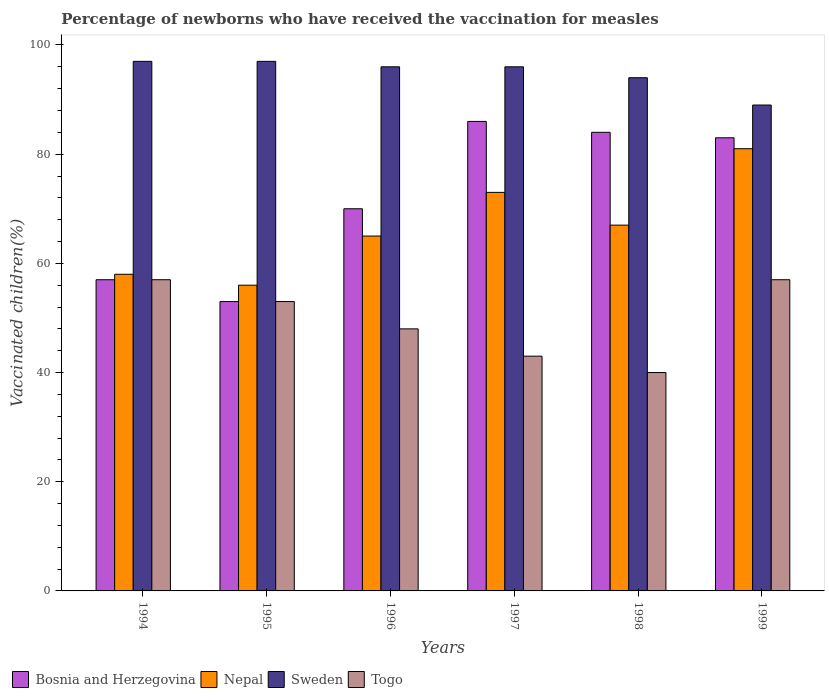How many groups of bars are there?
Your response must be concise. 6. Are the number of bars per tick equal to the number of legend labels?
Your response must be concise. Yes. Across all years, what is the maximum percentage of vaccinated children in Nepal?
Ensure brevity in your answer.  81. Across all years, what is the minimum percentage of vaccinated children in Nepal?
Provide a succinct answer. 56. What is the total percentage of vaccinated children in Nepal in the graph?
Ensure brevity in your answer.  400. What is the difference between the percentage of vaccinated children in Nepal in 1994 and that in 1997?
Provide a succinct answer. -15. What is the difference between the percentage of vaccinated children in Nepal in 1996 and the percentage of vaccinated children in Togo in 1995?
Provide a succinct answer. 12. What is the average percentage of vaccinated children in Bosnia and Herzegovina per year?
Provide a short and direct response. 72.17. In the year 1997, what is the difference between the percentage of vaccinated children in Sweden and percentage of vaccinated children in Nepal?
Ensure brevity in your answer.  23. In how many years, is the percentage of vaccinated children in Bosnia and Herzegovina greater than 76 %?
Provide a short and direct response. 3. What is the ratio of the percentage of vaccinated children in Nepal in 1996 to that in 1998?
Provide a succinct answer. 0.97. Is the percentage of vaccinated children in Sweden in 1996 less than that in 1997?
Provide a succinct answer. No. What is the difference between the highest and the lowest percentage of vaccinated children in Sweden?
Your answer should be very brief. 8. What does the 2nd bar from the left in 1995 represents?
Offer a very short reply. Nepal. What does the 1st bar from the right in 1999 represents?
Give a very brief answer. Togo. Are all the bars in the graph horizontal?
Provide a short and direct response. No. Does the graph contain grids?
Offer a very short reply. No. What is the title of the graph?
Provide a short and direct response. Percentage of newborns who have received the vaccination for measles. Does "Central Europe" appear as one of the legend labels in the graph?
Ensure brevity in your answer.  No. What is the label or title of the Y-axis?
Provide a short and direct response. Vaccinated children(%). What is the Vaccinated children(%) in Sweden in 1994?
Keep it short and to the point. 97. What is the Vaccinated children(%) of Bosnia and Herzegovina in 1995?
Give a very brief answer. 53. What is the Vaccinated children(%) of Nepal in 1995?
Your answer should be very brief. 56. What is the Vaccinated children(%) of Sweden in 1995?
Offer a terse response. 97. What is the Vaccinated children(%) of Togo in 1995?
Offer a very short reply. 53. What is the Vaccinated children(%) of Nepal in 1996?
Your answer should be compact. 65. What is the Vaccinated children(%) in Sweden in 1996?
Your answer should be very brief. 96. What is the Vaccinated children(%) of Nepal in 1997?
Keep it short and to the point. 73. What is the Vaccinated children(%) in Sweden in 1997?
Offer a terse response. 96. What is the Vaccinated children(%) of Togo in 1997?
Make the answer very short. 43. What is the Vaccinated children(%) of Bosnia and Herzegovina in 1998?
Your response must be concise. 84. What is the Vaccinated children(%) of Sweden in 1998?
Keep it short and to the point. 94. What is the Vaccinated children(%) of Togo in 1998?
Give a very brief answer. 40. What is the Vaccinated children(%) in Sweden in 1999?
Provide a short and direct response. 89. Across all years, what is the maximum Vaccinated children(%) in Sweden?
Provide a short and direct response. 97. Across all years, what is the maximum Vaccinated children(%) in Togo?
Keep it short and to the point. 57. Across all years, what is the minimum Vaccinated children(%) in Bosnia and Herzegovina?
Provide a succinct answer. 53. Across all years, what is the minimum Vaccinated children(%) of Sweden?
Ensure brevity in your answer.  89. What is the total Vaccinated children(%) in Bosnia and Herzegovina in the graph?
Your answer should be very brief. 433. What is the total Vaccinated children(%) in Sweden in the graph?
Keep it short and to the point. 569. What is the total Vaccinated children(%) in Togo in the graph?
Make the answer very short. 298. What is the difference between the Vaccinated children(%) in Bosnia and Herzegovina in 1994 and that in 1995?
Provide a short and direct response. 4. What is the difference between the Vaccinated children(%) in Nepal in 1994 and that in 1995?
Offer a terse response. 2. What is the difference between the Vaccinated children(%) in Togo in 1994 and that in 1995?
Make the answer very short. 4. What is the difference between the Vaccinated children(%) in Togo in 1994 and that in 1996?
Offer a terse response. 9. What is the difference between the Vaccinated children(%) in Bosnia and Herzegovina in 1994 and that in 1997?
Your answer should be very brief. -29. What is the difference between the Vaccinated children(%) in Sweden in 1994 and that in 1997?
Provide a succinct answer. 1. What is the difference between the Vaccinated children(%) in Togo in 1994 and that in 1997?
Keep it short and to the point. 14. What is the difference between the Vaccinated children(%) of Sweden in 1994 and that in 1999?
Make the answer very short. 8. What is the difference between the Vaccinated children(%) in Togo in 1994 and that in 1999?
Provide a short and direct response. 0. What is the difference between the Vaccinated children(%) in Bosnia and Herzegovina in 1995 and that in 1996?
Provide a succinct answer. -17. What is the difference between the Vaccinated children(%) in Togo in 1995 and that in 1996?
Make the answer very short. 5. What is the difference between the Vaccinated children(%) of Bosnia and Herzegovina in 1995 and that in 1997?
Make the answer very short. -33. What is the difference between the Vaccinated children(%) in Sweden in 1995 and that in 1997?
Your answer should be compact. 1. What is the difference between the Vaccinated children(%) of Togo in 1995 and that in 1997?
Provide a succinct answer. 10. What is the difference between the Vaccinated children(%) of Bosnia and Herzegovina in 1995 and that in 1998?
Your answer should be very brief. -31. What is the difference between the Vaccinated children(%) of Nepal in 1995 and that in 1998?
Give a very brief answer. -11. What is the difference between the Vaccinated children(%) in Sweden in 1995 and that in 1998?
Ensure brevity in your answer.  3. What is the difference between the Vaccinated children(%) in Nepal in 1996 and that in 1997?
Offer a terse response. -8. What is the difference between the Vaccinated children(%) of Sweden in 1996 and that in 1997?
Make the answer very short. 0. What is the difference between the Vaccinated children(%) in Togo in 1996 and that in 1997?
Make the answer very short. 5. What is the difference between the Vaccinated children(%) of Nepal in 1996 and that in 1998?
Offer a very short reply. -2. What is the difference between the Vaccinated children(%) in Sweden in 1996 and that in 1998?
Give a very brief answer. 2. What is the difference between the Vaccinated children(%) in Togo in 1996 and that in 1998?
Ensure brevity in your answer.  8. What is the difference between the Vaccinated children(%) of Bosnia and Herzegovina in 1996 and that in 1999?
Your response must be concise. -13. What is the difference between the Vaccinated children(%) of Sweden in 1996 and that in 1999?
Offer a very short reply. 7. What is the difference between the Vaccinated children(%) in Togo in 1996 and that in 1999?
Your response must be concise. -9. What is the difference between the Vaccinated children(%) in Bosnia and Herzegovina in 1997 and that in 1998?
Ensure brevity in your answer.  2. What is the difference between the Vaccinated children(%) in Sweden in 1997 and that in 1999?
Offer a terse response. 7. What is the difference between the Vaccinated children(%) in Bosnia and Herzegovina in 1998 and that in 1999?
Make the answer very short. 1. What is the difference between the Vaccinated children(%) in Nepal in 1998 and that in 1999?
Give a very brief answer. -14. What is the difference between the Vaccinated children(%) in Bosnia and Herzegovina in 1994 and the Vaccinated children(%) in Togo in 1995?
Offer a terse response. 4. What is the difference between the Vaccinated children(%) of Nepal in 1994 and the Vaccinated children(%) of Sweden in 1995?
Your answer should be very brief. -39. What is the difference between the Vaccinated children(%) in Bosnia and Herzegovina in 1994 and the Vaccinated children(%) in Sweden in 1996?
Ensure brevity in your answer.  -39. What is the difference between the Vaccinated children(%) in Bosnia and Herzegovina in 1994 and the Vaccinated children(%) in Togo in 1996?
Give a very brief answer. 9. What is the difference between the Vaccinated children(%) in Nepal in 1994 and the Vaccinated children(%) in Sweden in 1996?
Your answer should be compact. -38. What is the difference between the Vaccinated children(%) in Sweden in 1994 and the Vaccinated children(%) in Togo in 1996?
Make the answer very short. 49. What is the difference between the Vaccinated children(%) in Bosnia and Herzegovina in 1994 and the Vaccinated children(%) in Nepal in 1997?
Your response must be concise. -16. What is the difference between the Vaccinated children(%) of Bosnia and Herzegovina in 1994 and the Vaccinated children(%) of Sweden in 1997?
Your answer should be compact. -39. What is the difference between the Vaccinated children(%) in Nepal in 1994 and the Vaccinated children(%) in Sweden in 1997?
Ensure brevity in your answer.  -38. What is the difference between the Vaccinated children(%) in Nepal in 1994 and the Vaccinated children(%) in Togo in 1997?
Keep it short and to the point. 15. What is the difference between the Vaccinated children(%) of Bosnia and Herzegovina in 1994 and the Vaccinated children(%) of Nepal in 1998?
Your answer should be compact. -10. What is the difference between the Vaccinated children(%) in Bosnia and Herzegovina in 1994 and the Vaccinated children(%) in Sweden in 1998?
Your response must be concise. -37. What is the difference between the Vaccinated children(%) in Nepal in 1994 and the Vaccinated children(%) in Sweden in 1998?
Keep it short and to the point. -36. What is the difference between the Vaccinated children(%) of Bosnia and Herzegovina in 1994 and the Vaccinated children(%) of Nepal in 1999?
Keep it short and to the point. -24. What is the difference between the Vaccinated children(%) in Bosnia and Herzegovina in 1994 and the Vaccinated children(%) in Sweden in 1999?
Ensure brevity in your answer.  -32. What is the difference between the Vaccinated children(%) of Bosnia and Herzegovina in 1994 and the Vaccinated children(%) of Togo in 1999?
Make the answer very short. 0. What is the difference between the Vaccinated children(%) of Nepal in 1994 and the Vaccinated children(%) of Sweden in 1999?
Ensure brevity in your answer.  -31. What is the difference between the Vaccinated children(%) of Nepal in 1994 and the Vaccinated children(%) of Togo in 1999?
Offer a very short reply. 1. What is the difference between the Vaccinated children(%) in Sweden in 1994 and the Vaccinated children(%) in Togo in 1999?
Ensure brevity in your answer.  40. What is the difference between the Vaccinated children(%) in Bosnia and Herzegovina in 1995 and the Vaccinated children(%) in Nepal in 1996?
Ensure brevity in your answer.  -12. What is the difference between the Vaccinated children(%) of Bosnia and Herzegovina in 1995 and the Vaccinated children(%) of Sweden in 1996?
Ensure brevity in your answer.  -43. What is the difference between the Vaccinated children(%) of Nepal in 1995 and the Vaccinated children(%) of Togo in 1996?
Keep it short and to the point. 8. What is the difference between the Vaccinated children(%) of Bosnia and Herzegovina in 1995 and the Vaccinated children(%) of Sweden in 1997?
Provide a succinct answer. -43. What is the difference between the Vaccinated children(%) in Nepal in 1995 and the Vaccinated children(%) in Togo in 1997?
Give a very brief answer. 13. What is the difference between the Vaccinated children(%) in Sweden in 1995 and the Vaccinated children(%) in Togo in 1997?
Offer a terse response. 54. What is the difference between the Vaccinated children(%) in Bosnia and Herzegovina in 1995 and the Vaccinated children(%) in Nepal in 1998?
Your answer should be compact. -14. What is the difference between the Vaccinated children(%) in Bosnia and Herzegovina in 1995 and the Vaccinated children(%) in Sweden in 1998?
Offer a terse response. -41. What is the difference between the Vaccinated children(%) in Bosnia and Herzegovina in 1995 and the Vaccinated children(%) in Togo in 1998?
Your answer should be very brief. 13. What is the difference between the Vaccinated children(%) in Nepal in 1995 and the Vaccinated children(%) in Sweden in 1998?
Give a very brief answer. -38. What is the difference between the Vaccinated children(%) in Sweden in 1995 and the Vaccinated children(%) in Togo in 1998?
Give a very brief answer. 57. What is the difference between the Vaccinated children(%) in Bosnia and Herzegovina in 1995 and the Vaccinated children(%) in Nepal in 1999?
Make the answer very short. -28. What is the difference between the Vaccinated children(%) in Bosnia and Herzegovina in 1995 and the Vaccinated children(%) in Sweden in 1999?
Make the answer very short. -36. What is the difference between the Vaccinated children(%) in Nepal in 1995 and the Vaccinated children(%) in Sweden in 1999?
Keep it short and to the point. -33. What is the difference between the Vaccinated children(%) of Nepal in 1996 and the Vaccinated children(%) of Sweden in 1997?
Ensure brevity in your answer.  -31. What is the difference between the Vaccinated children(%) of Sweden in 1996 and the Vaccinated children(%) of Togo in 1997?
Make the answer very short. 53. What is the difference between the Vaccinated children(%) in Bosnia and Herzegovina in 1996 and the Vaccinated children(%) in Nepal in 1998?
Your answer should be very brief. 3. What is the difference between the Vaccinated children(%) of Bosnia and Herzegovina in 1996 and the Vaccinated children(%) of Sweden in 1998?
Offer a very short reply. -24. What is the difference between the Vaccinated children(%) of Sweden in 1996 and the Vaccinated children(%) of Togo in 1998?
Provide a short and direct response. 56. What is the difference between the Vaccinated children(%) in Bosnia and Herzegovina in 1996 and the Vaccinated children(%) in Nepal in 1999?
Offer a very short reply. -11. What is the difference between the Vaccinated children(%) in Bosnia and Herzegovina in 1996 and the Vaccinated children(%) in Sweden in 1999?
Your answer should be compact. -19. What is the difference between the Vaccinated children(%) of Bosnia and Herzegovina in 1996 and the Vaccinated children(%) of Togo in 1999?
Offer a terse response. 13. What is the difference between the Vaccinated children(%) in Sweden in 1996 and the Vaccinated children(%) in Togo in 1999?
Offer a terse response. 39. What is the difference between the Vaccinated children(%) in Bosnia and Herzegovina in 1997 and the Vaccinated children(%) in Nepal in 1998?
Keep it short and to the point. 19. What is the difference between the Vaccinated children(%) in Bosnia and Herzegovina in 1997 and the Vaccinated children(%) in Sweden in 1998?
Your answer should be compact. -8. What is the difference between the Vaccinated children(%) of Nepal in 1997 and the Vaccinated children(%) of Sweden in 1998?
Your answer should be compact. -21. What is the difference between the Vaccinated children(%) of Nepal in 1997 and the Vaccinated children(%) of Togo in 1998?
Keep it short and to the point. 33. What is the difference between the Vaccinated children(%) of Sweden in 1997 and the Vaccinated children(%) of Togo in 1998?
Make the answer very short. 56. What is the difference between the Vaccinated children(%) in Bosnia and Herzegovina in 1997 and the Vaccinated children(%) in Sweden in 1999?
Ensure brevity in your answer.  -3. What is the difference between the Vaccinated children(%) in Nepal in 1997 and the Vaccinated children(%) in Sweden in 1999?
Keep it short and to the point. -16. What is the difference between the Vaccinated children(%) of Bosnia and Herzegovina in 1998 and the Vaccinated children(%) of Sweden in 1999?
Your answer should be very brief. -5. What is the difference between the Vaccinated children(%) of Nepal in 1998 and the Vaccinated children(%) of Sweden in 1999?
Provide a short and direct response. -22. What is the difference between the Vaccinated children(%) of Sweden in 1998 and the Vaccinated children(%) of Togo in 1999?
Keep it short and to the point. 37. What is the average Vaccinated children(%) of Bosnia and Herzegovina per year?
Make the answer very short. 72.17. What is the average Vaccinated children(%) in Nepal per year?
Your answer should be very brief. 66.67. What is the average Vaccinated children(%) in Sweden per year?
Provide a short and direct response. 94.83. What is the average Vaccinated children(%) in Togo per year?
Ensure brevity in your answer.  49.67. In the year 1994, what is the difference between the Vaccinated children(%) of Bosnia and Herzegovina and Vaccinated children(%) of Togo?
Your response must be concise. 0. In the year 1994, what is the difference between the Vaccinated children(%) of Nepal and Vaccinated children(%) of Sweden?
Offer a terse response. -39. In the year 1994, what is the difference between the Vaccinated children(%) of Nepal and Vaccinated children(%) of Togo?
Offer a terse response. 1. In the year 1994, what is the difference between the Vaccinated children(%) in Sweden and Vaccinated children(%) in Togo?
Make the answer very short. 40. In the year 1995, what is the difference between the Vaccinated children(%) of Bosnia and Herzegovina and Vaccinated children(%) of Sweden?
Your answer should be very brief. -44. In the year 1995, what is the difference between the Vaccinated children(%) in Nepal and Vaccinated children(%) in Sweden?
Make the answer very short. -41. In the year 1995, what is the difference between the Vaccinated children(%) in Nepal and Vaccinated children(%) in Togo?
Your answer should be very brief. 3. In the year 1995, what is the difference between the Vaccinated children(%) in Sweden and Vaccinated children(%) in Togo?
Ensure brevity in your answer.  44. In the year 1996, what is the difference between the Vaccinated children(%) of Bosnia and Herzegovina and Vaccinated children(%) of Nepal?
Your answer should be compact. 5. In the year 1996, what is the difference between the Vaccinated children(%) of Bosnia and Herzegovina and Vaccinated children(%) of Togo?
Ensure brevity in your answer.  22. In the year 1996, what is the difference between the Vaccinated children(%) of Nepal and Vaccinated children(%) of Sweden?
Make the answer very short. -31. In the year 1996, what is the difference between the Vaccinated children(%) of Nepal and Vaccinated children(%) of Togo?
Offer a terse response. 17. In the year 1997, what is the difference between the Vaccinated children(%) in Bosnia and Herzegovina and Vaccinated children(%) in Nepal?
Your response must be concise. 13. In the year 1997, what is the difference between the Vaccinated children(%) in Bosnia and Herzegovina and Vaccinated children(%) in Sweden?
Keep it short and to the point. -10. In the year 1997, what is the difference between the Vaccinated children(%) in Bosnia and Herzegovina and Vaccinated children(%) in Togo?
Your answer should be very brief. 43. In the year 1997, what is the difference between the Vaccinated children(%) in Sweden and Vaccinated children(%) in Togo?
Your response must be concise. 53. In the year 1998, what is the difference between the Vaccinated children(%) in Bosnia and Herzegovina and Vaccinated children(%) in Nepal?
Your answer should be very brief. 17. In the year 1998, what is the difference between the Vaccinated children(%) in Bosnia and Herzegovina and Vaccinated children(%) in Sweden?
Your answer should be compact. -10. In the year 1998, what is the difference between the Vaccinated children(%) in Bosnia and Herzegovina and Vaccinated children(%) in Togo?
Make the answer very short. 44. In the year 1998, what is the difference between the Vaccinated children(%) of Sweden and Vaccinated children(%) of Togo?
Your answer should be compact. 54. In the year 1999, what is the difference between the Vaccinated children(%) of Bosnia and Herzegovina and Vaccinated children(%) of Sweden?
Give a very brief answer. -6. In the year 1999, what is the difference between the Vaccinated children(%) of Nepal and Vaccinated children(%) of Sweden?
Make the answer very short. -8. In the year 1999, what is the difference between the Vaccinated children(%) in Sweden and Vaccinated children(%) in Togo?
Your answer should be very brief. 32. What is the ratio of the Vaccinated children(%) of Bosnia and Herzegovina in 1994 to that in 1995?
Provide a short and direct response. 1.08. What is the ratio of the Vaccinated children(%) in Nepal in 1994 to that in 1995?
Your answer should be very brief. 1.04. What is the ratio of the Vaccinated children(%) of Togo in 1994 to that in 1995?
Provide a short and direct response. 1.08. What is the ratio of the Vaccinated children(%) in Bosnia and Herzegovina in 1994 to that in 1996?
Your answer should be compact. 0.81. What is the ratio of the Vaccinated children(%) of Nepal in 1994 to that in 1996?
Your response must be concise. 0.89. What is the ratio of the Vaccinated children(%) of Sweden in 1994 to that in 1996?
Make the answer very short. 1.01. What is the ratio of the Vaccinated children(%) of Togo in 1994 to that in 1996?
Offer a terse response. 1.19. What is the ratio of the Vaccinated children(%) in Bosnia and Herzegovina in 1994 to that in 1997?
Provide a succinct answer. 0.66. What is the ratio of the Vaccinated children(%) in Nepal in 1994 to that in 1997?
Provide a succinct answer. 0.79. What is the ratio of the Vaccinated children(%) in Sweden in 1994 to that in 1997?
Give a very brief answer. 1.01. What is the ratio of the Vaccinated children(%) in Togo in 1994 to that in 1997?
Your response must be concise. 1.33. What is the ratio of the Vaccinated children(%) of Bosnia and Herzegovina in 1994 to that in 1998?
Ensure brevity in your answer.  0.68. What is the ratio of the Vaccinated children(%) in Nepal in 1994 to that in 1998?
Your answer should be very brief. 0.87. What is the ratio of the Vaccinated children(%) of Sweden in 1994 to that in 1998?
Offer a terse response. 1.03. What is the ratio of the Vaccinated children(%) of Togo in 1994 to that in 1998?
Give a very brief answer. 1.43. What is the ratio of the Vaccinated children(%) in Bosnia and Herzegovina in 1994 to that in 1999?
Make the answer very short. 0.69. What is the ratio of the Vaccinated children(%) of Nepal in 1994 to that in 1999?
Ensure brevity in your answer.  0.72. What is the ratio of the Vaccinated children(%) in Sweden in 1994 to that in 1999?
Keep it short and to the point. 1.09. What is the ratio of the Vaccinated children(%) of Togo in 1994 to that in 1999?
Provide a succinct answer. 1. What is the ratio of the Vaccinated children(%) in Bosnia and Herzegovina in 1995 to that in 1996?
Offer a terse response. 0.76. What is the ratio of the Vaccinated children(%) of Nepal in 1995 to that in 1996?
Ensure brevity in your answer.  0.86. What is the ratio of the Vaccinated children(%) in Sweden in 1995 to that in 1996?
Provide a succinct answer. 1.01. What is the ratio of the Vaccinated children(%) of Togo in 1995 to that in 1996?
Ensure brevity in your answer.  1.1. What is the ratio of the Vaccinated children(%) of Bosnia and Herzegovina in 1995 to that in 1997?
Keep it short and to the point. 0.62. What is the ratio of the Vaccinated children(%) of Nepal in 1995 to that in 1997?
Offer a terse response. 0.77. What is the ratio of the Vaccinated children(%) of Sweden in 1995 to that in 1997?
Offer a terse response. 1.01. What is the ratio of the Vaccinated children(%) in Togo in 1995 to that in 1997?
Your answer should be very brief. 1.23. What is the ratio of the Vaccinated children(%) of Bosnia and Herzegovina in 1995 to that in 1998?
Your answer should be very brief. 0.63. What is the ratio of the Vaccinated children(%) of Nepal in 1995 to that in 1998?
Make the answer very short. 0.84. What is the ratio of the Vaccinated children(%) of Sweden in 1995 to that in 1998?
Ensure brevity in your answer.  1.03. What is the ratio of the Vaccinated children(%) in Togo in 1995 to that in 1998?
Give a very brief answer. 1.32. What is the ratio of the Vaccinated children(%) in Bosnia and Herzegovina in 1995 to that in 1999?
Your answer should be very brief. 0.64. What is the ratio of the Vaccinated children(%) in Nepal in 1995 to that in 1999?
Provide a succinct answer. 0.69. What is the ratio of the Vaccinated children(%) in Sweden in 1995 to that in 1999?
Offer a terse response. 1.09. What is the ratio of the Vaccinated children(%) in Togo in 1995 to that in 1999?
Provide a short and direct response. 0.93. What is the ratio of the Vaccinated children(%) of Bosnia and Herzegovina in 1996 to that in 1997?
Your answer should be compact. 0.81. What is the ratio of the Vaccinated children(%) of Nepal in 1996 to that in 1997?
Your response must be concise. 0.89. What is the ratio of the Vaccinated children(%) in Togo in 1996 to that in 1997?
Ensure brevity in your answer.  1.12. What is the ratio of the Vaccinated children(%) in Bosnia and Herzegovina in 1996 to that in 1998?
Offer a terse response. 0.83. What is the ratio of the Vaccinated children(%) in Nepal in 1996 to that in 1998?
Offer a very short reply. 0.97. What is the ratio of the Vaccinated children(%) of Sweden in 1996 to that in 1998?
Provide a short and direct response. 1.02. What is the ratio of the Vaccinated children(%) of Togo in 1996 to that in 1998?
Provide a short and direct response. 1.2. What is the ratio of the Vaccinated children(%) in Bosnia and Herzegovina in 1996 to that in 1999?
Your response must be concise. 0.84. What is the ratio of the Vaccinated children(%) of Nepal in 1996 to that in 1999?
Your answer should be compact. 0.8. What is the ratio of the Vaccinated children(%) in Sweden in 1996 to that in 1999?
Offer a very short reply. 1.08. What is the ratio of the Vaccinated children(%) of Togo in 1996 to that in 1999?
Ensure brevity in your answer.  0.84. What is the ratio of the Vaccinated children(%) of Bosnia and Herzegovina in 1997 to that in 1998?
Make the answer very short. 1.02. What is the ratio of the Vaccinated children(%) of Nepal in 1997 to that in 1998?
Provide a short and direct response. 1.09. What is the ratio of the Vaccinated children(%) in Sweden in 1997 to that in 1998?
Your response must be concise. 1.02. What is the ratio of the Vaccinated children(%) in Togo in 1997 to that in 1998?
Provide a succinct answer. 1.07. What is the ratio of the Vaccinated children(%) in Bosnia and Herzegovina in 1997 to that in 1999?
Offer a very short reply. 1.04. What is the ratio of the Vaccinated children(%) in Nepal in 1997 to that in 1999?
Your answer should be very brief. 0.9. What is the ratio of the Vaccinated children(%) of Sweden in 1997 to that in 1999?
Your answer should be compact. 1.08. What is the ratio of the Vaccinated children(%) of Togo in 1997 to that in 1999?
Your answer should be very brief. 0.75. What is the ratio of the Vaccinated children(%) in Nepal in 1998 to that in 1999?
Keep it short and to the point. 0.83. What is the ratio of the Vaccinated children(%) in Sweden in 1998 to that in 1999?
Ensure brevity in your answer.  1.06. What is the ratio of the Vaccinated children(%) of Togo in 1998 to that in 1999?
Provide a succinct answer. 0.7. What is the difference between the highest and the second highest Vaccinated children(%) in Nepal?
Keep it short and to the point. 8. What is the difference between the highest and the second highest Vaccinated children(%) in Sweden?
Your answer should be compact. 0. What is the difference between the highest and the lowest Vaccinated children(%) in Bosnia and Herzegovina?
Ensure brevity in your answer.  33. What is the difference between the highest and the lowest Vaccinated children(%) in Nepal?
Ensure brevity in your answer.  25. 